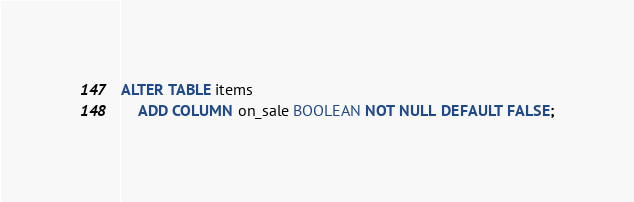Convert code to text. <code><loc_0><loc_0><loc_500><loc_500><_SQL_>ALTER TABLE items
    ADD COLUMN on_sale BOOLEAN NOT NULL DEFAULT FALSE;</code> 